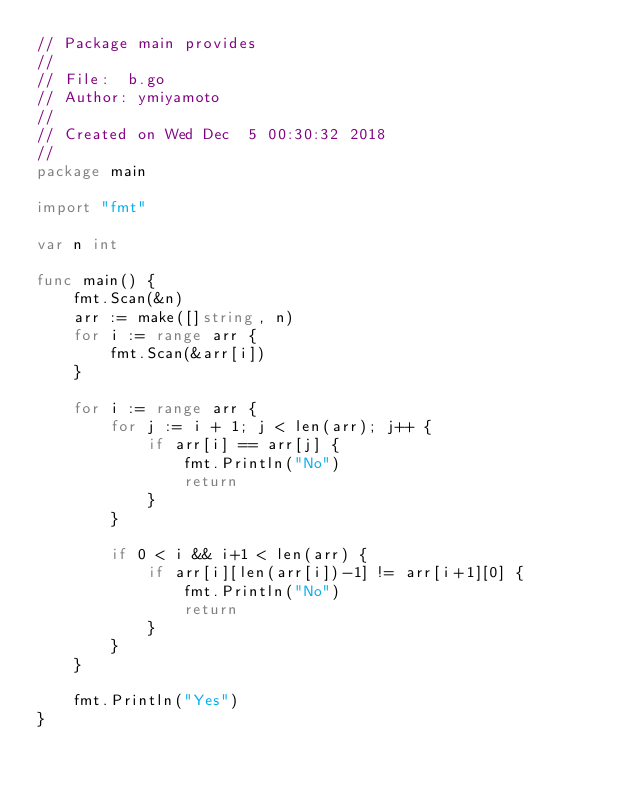<code> <loc_0><loc_0><loc_500><loc_500><_Go_>// Package main provides
//
// File:  b.go
// Author: ymiyamoto
//
// Created on Wed Dec  5 00:30:32 2018
//
package main

import "fmt"

var n int

func main() {
	fmt.Scan(&n)
	arr := make([]string, n)
	for i := range arr {
		fmt.Scan(&arr[i])
	}

	for i := range arr {
		for j := i + 1; j < len(arr); j++ {
			if arr[i] == arr[j] {
				fmt.Println("No")
				return
			}
		}

		if 0 < i && i+1 < len(arr) {
			if arr[i][len(arr[i])-1] != arr[i+1][0] {
				fmt.Println("No")
				return
			}
		}
	}

	fmt.Println("Yes")
}
</code> 